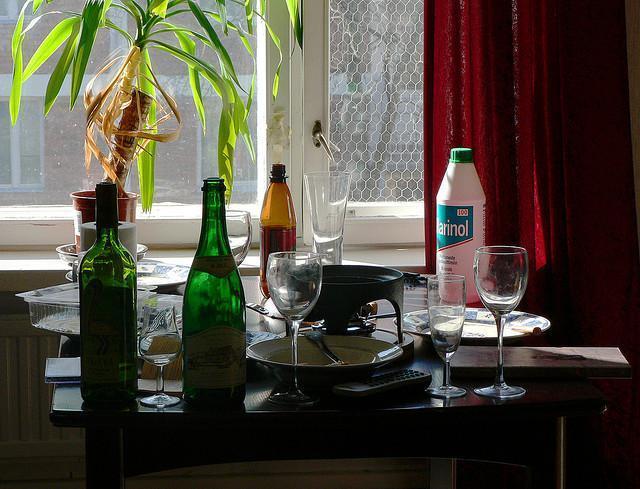How many glasses are set?
Give a very brief answer. 4. How many glasses are there?
Give a very brief answer. 5. How many bottles are there?
Give a very brief answer. 4. How many wine glasses can you see?
Give a very brief answer. 5. How many dining tables are there?
Give a very brief answer. 2. 